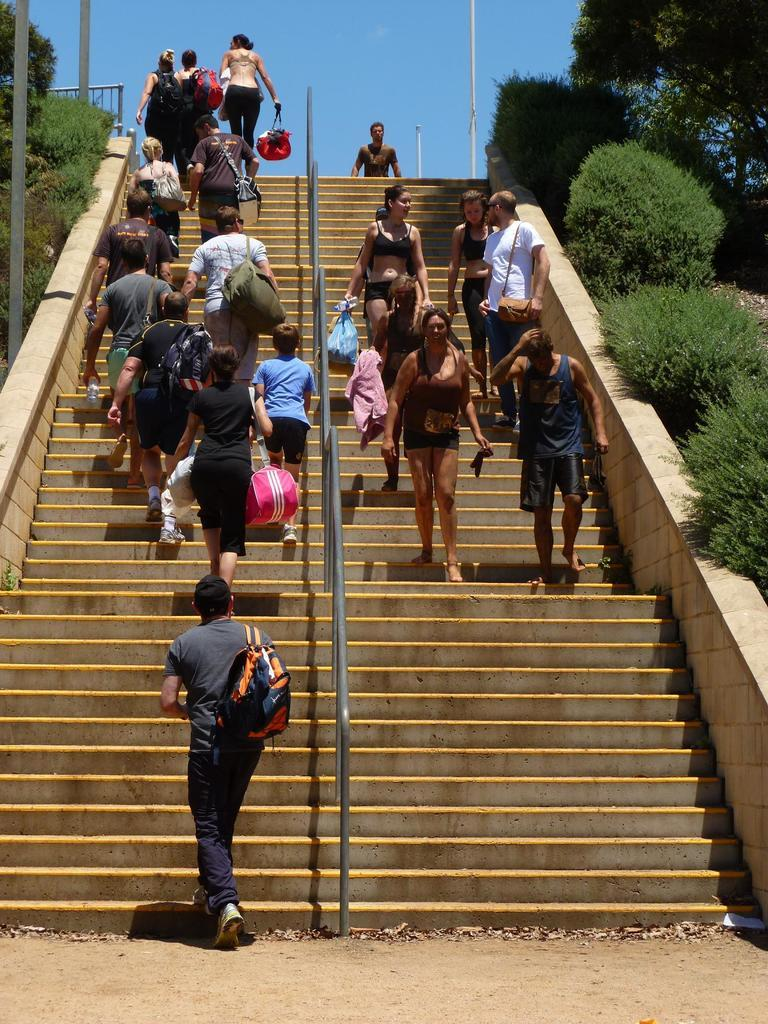What are the people in the image doing? There is a group of people standing on the staircase. What object can be seen in the image besides the people and staircase? There is a metal rod in the image. What type of vegetation is near the staircase? There are trees beside the staircase. What other structures are present in the image? There are poles in the image. What is visible at the top of the image? The sky is visible at the top of the image. What type of mint is growing on the staircase in the image? There is no mint growing on the staircase in the image. What is the belief of the people standing on the staircase? The image does not provide any information about the beliefs of the people standing on the staircase. 